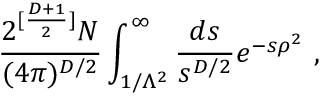Convert formula to latex. <formula><loc_0><loc_0><loc_500><loc_500>\frac { 2 ^ { [ \frac { D + 1 } { 2 } ] } N } { ( 4 \pi ) ^ { D / 2 } } \int _ { 1 / \Lambda ^ { 2 } } ^ { \infty } \frac { d s } { s ^ { D / 2 } } e ^ { - s \rho ^ { 2 } } ,</formula> 